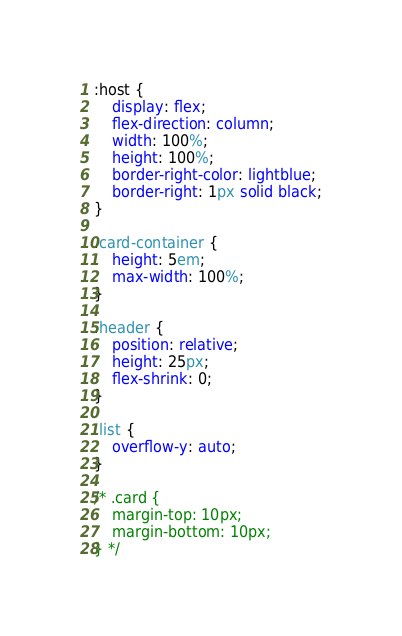Convert code to text. <code><loc_0><loc_0><loc_500><loc_500><_CSS_>
:host {
    display: flex;
    flex-direction: column;
    width: 100%;
    height: 100%;
    border-right-color: lightblue;
    border-right: 1px solid black;
}

.card-container {
    height: 5em;
    max-width: 100%;
}

.header {
    position: relative;
    height: 25px;
    flex-shrink: 0;
}

.list {
    overflow-y: auto;
}

/* .card {
    margin-top: 10px;
    margin-bottom: 10px;
} */</code> 